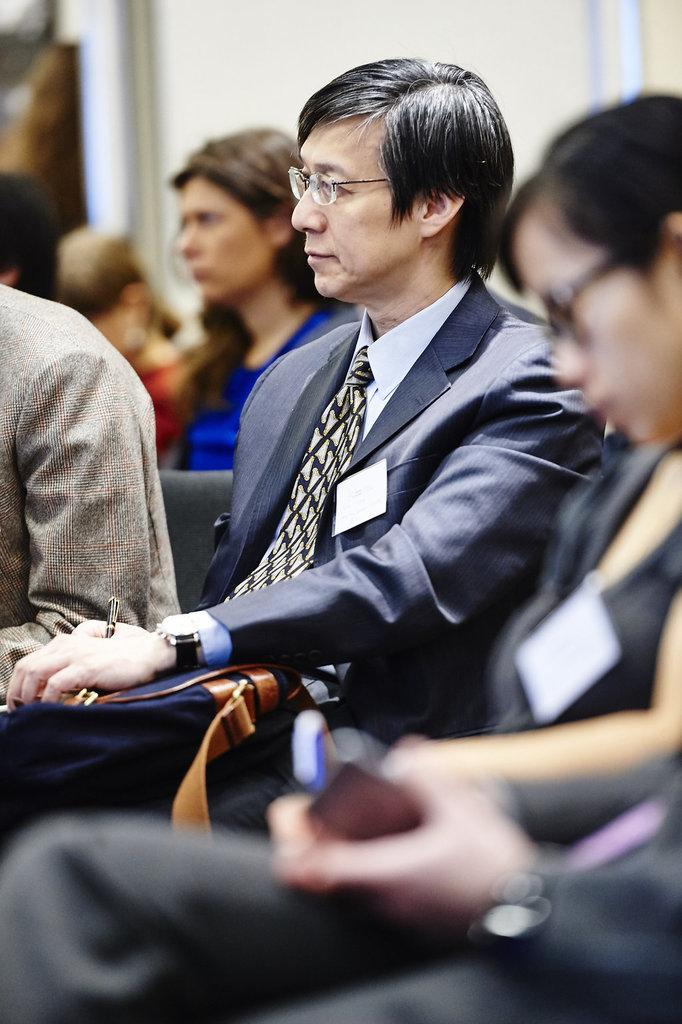How many people are sitting in the foreground of the image? There are four persons sitting in the foreground of the image. What are two objects being held by the men in the foreground? A man is holding a pen, and another man is holding a bag in the foreground. Can you describe the background of the image? There are persons sitting in the background of the image, and there is a white wall in the background. What type of trouble is the bucket causing in the image? There is no bucket present in the image, so it cannot cause any trouble. 